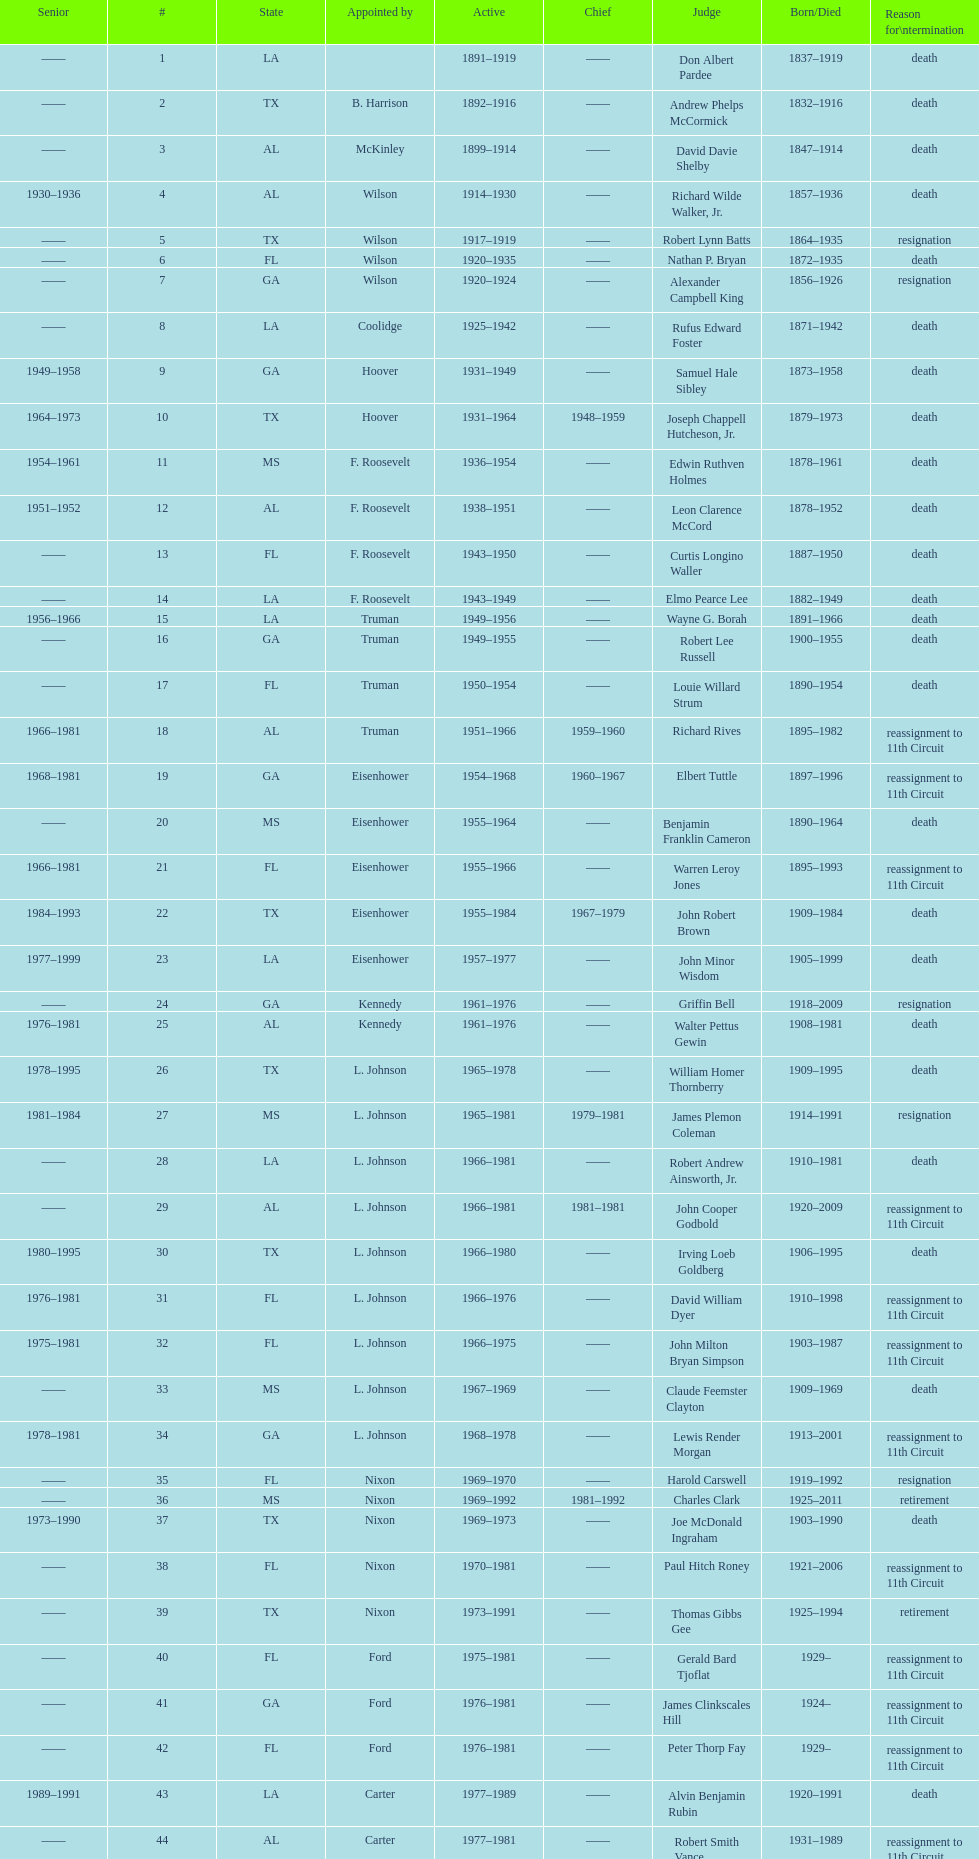How many judges were appointed by president carter? 13. 